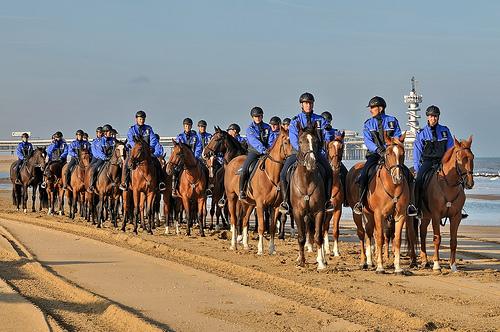Do they all wear black helmets?
Be succinct. Yes. How many people are wearing hats?
Keep it brief. 20. How many horses can you see?
Quick response, please. 20. What kind of ground cover is this?
Give a very brief answer. Sand. Where are they?
Short answer required. Beach. 